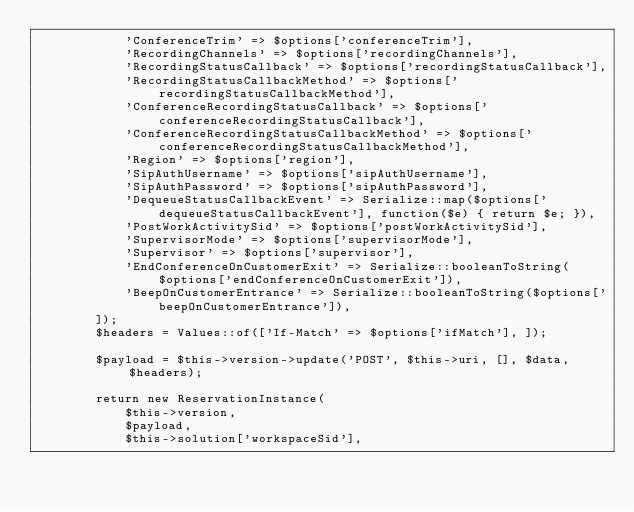Convert code to text. <code><loc_0><loc_0><loc_500><loc_500><_PHP_>            'ConferenceTrim' => $options['conferenceTrim'],
            'RecordingChannels' => $options['recordingChannels'],
            'RecordingStatusCallback' => $options['recordingStatusCallback'],
            'RecordingStatusCallbackMethod' => $options['recordingStatusCallbackMethod'],
            'ConferenceRecordingStatusCallback' => $options['conferenceRecordingStatusCallback'],
            'ConferenceRecordingStatusCallbackMethod' => $options['conferenceRecordingStatusCallbackMethod'],
            'Region' => $options['region'],
            'SipAuthUsername' => $options['sipAuthUsername'],
            'SipAuthPassword' => $options['sipAuthPassword'],
            'DequeueStatusCallbackEvent' => Serialize::map($options['dequeueStatusCallbackEvent'], function($e) { return $e; }),
            'PostWorkActivitySid' => $options['postWorkActivitySid'],
            'SupervisorMode' => $options['supervisorMode'],
            'Supervisor' => $options['supervisor'],
            'EndConferenceOnCustomerExit' => Serialize::booleanToString($options['endConferenceOnCustomerExit']),
            'BeepOnCustomerEntrance' => Serialize::booleanToString($options['beepOnCustomerEntrance']),
        ]);
        $headers = Values::of(['If-Match' => $options['ifMatch'], ]);

        $payload = $this->version->update('POST', $this->uri, [], $data, $headers);

        return new ReservationInstance(
            $this->version,
            $payload,
            $this->solution['workspaceSid'],</code> 